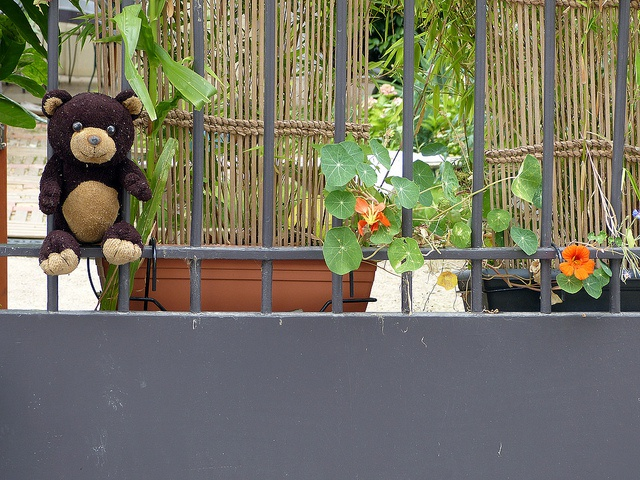Describe the objects in this image and their specific colors. I can see potted plant in black, green, olive, ivory, and gray tones and teddy bear in black, tan, and gray tones in this image. 